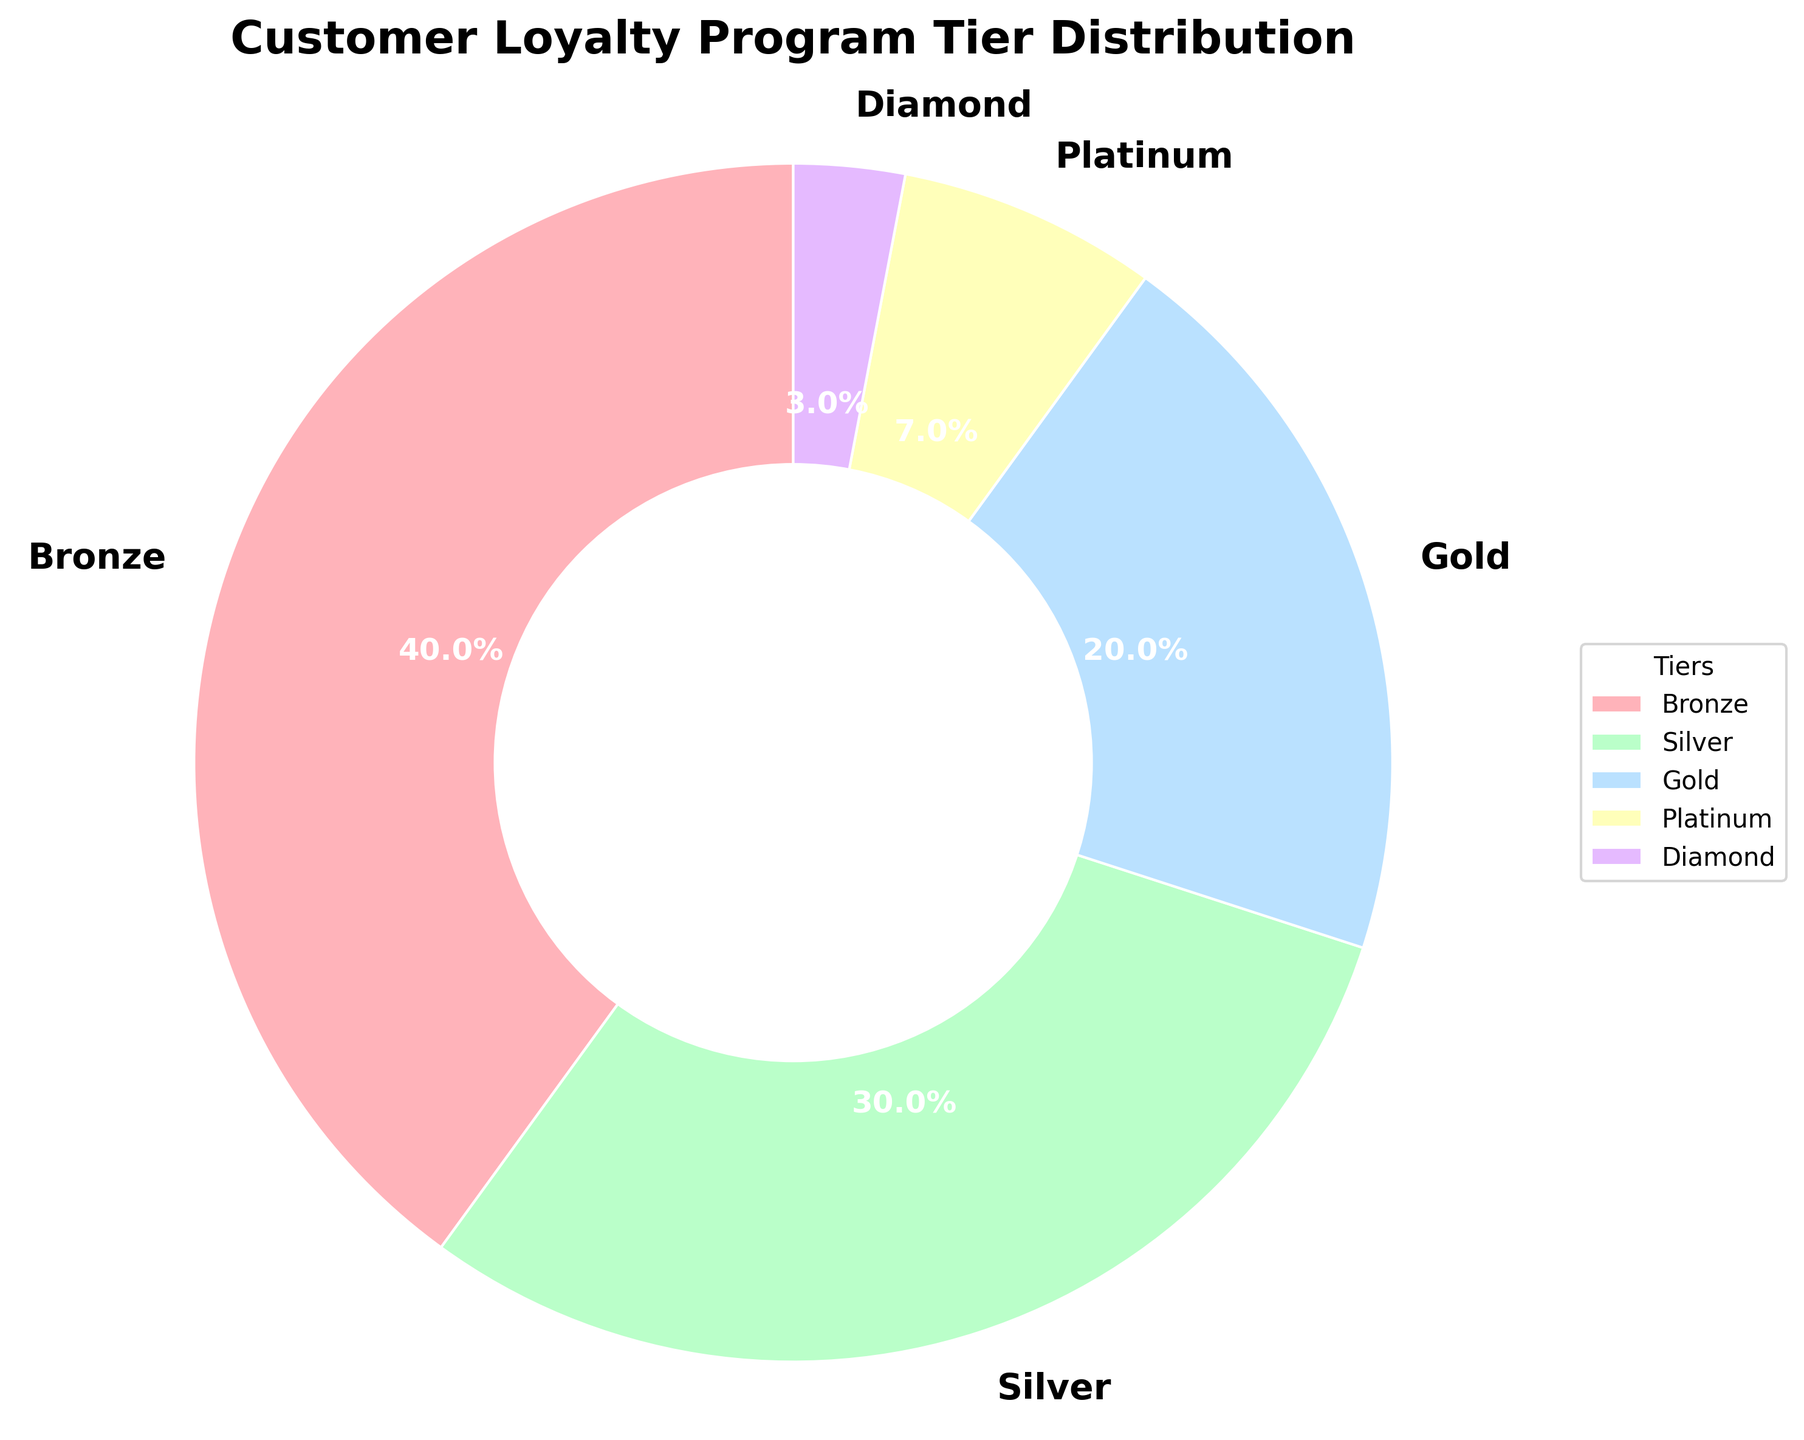What is the most common loyalty program tier? To find the most common tier, look at the slice of the pie chart with the largest percentage. The chart shows that the Bronze tier has 40%, which is the highest percentage among all tiers.
Answer: Bronze Which tier has the smallest representation? To determine the smallest representation, locate the slice of the pie chart with the smallest percentage. The Diamond tier has 3%, which is the smallest percentage.
Answer: Diamond How much larger is the Bronze tier compared to the Gold tier? To find the difference, subtract the percentage of the Gold tier from the Bronze tier: 40% (Bronze) - 20% (Gold) = 20%.
Answer: 20% If you combine the Silver and Platinum tiers, what is their total percentage? Add the percentages of the Silver and Platinum tiers: 30% (Silver) + 7% (Platinum) = 37%.
Answer: 37% Which tier is larger: Silver or Gold? Compare the percentage of the Silver tier (30%) to the Gold tier (20%). The Silver tier has a higher percentage.
Answer: Silver What percentage of customers are in tiers below Gold? Add the percentages of the Bronze and Silver tiers: 40% (Bronze) + 30% (Silver) = 70%.
Answer: 70% By how much does the Platinum tier exceed the Diamond tier? Subtract the percentage of the Diamond tier from the Platinum tier: 7% (Platinum) - 3% (Diamond) = 4%.
Answer: 4% What is the percentage difference between the Bronze and Diamond tiers? Subtract the percentage of the Diamond tier from the Bronze tier: 40% (Bronze) - 3% (Diamond) = 37%.
Answer: 37% Which tier occupies the middle position in terms of percentage? To find the middle value in the list of percentages (3%, 7%, 20%, 30%, 40%), identify the median. The Gold tier with 20% is the middle value.
Answer: Gold What are the combined percentages of the Gold, Platinum, and Diamond tiers? Add the percentages of the Gold, Platinum, and Diamond tiers: 20% (Gold) + 7% (Platinum) + 3% (Diamond) = 30%.
Answer: 30% 